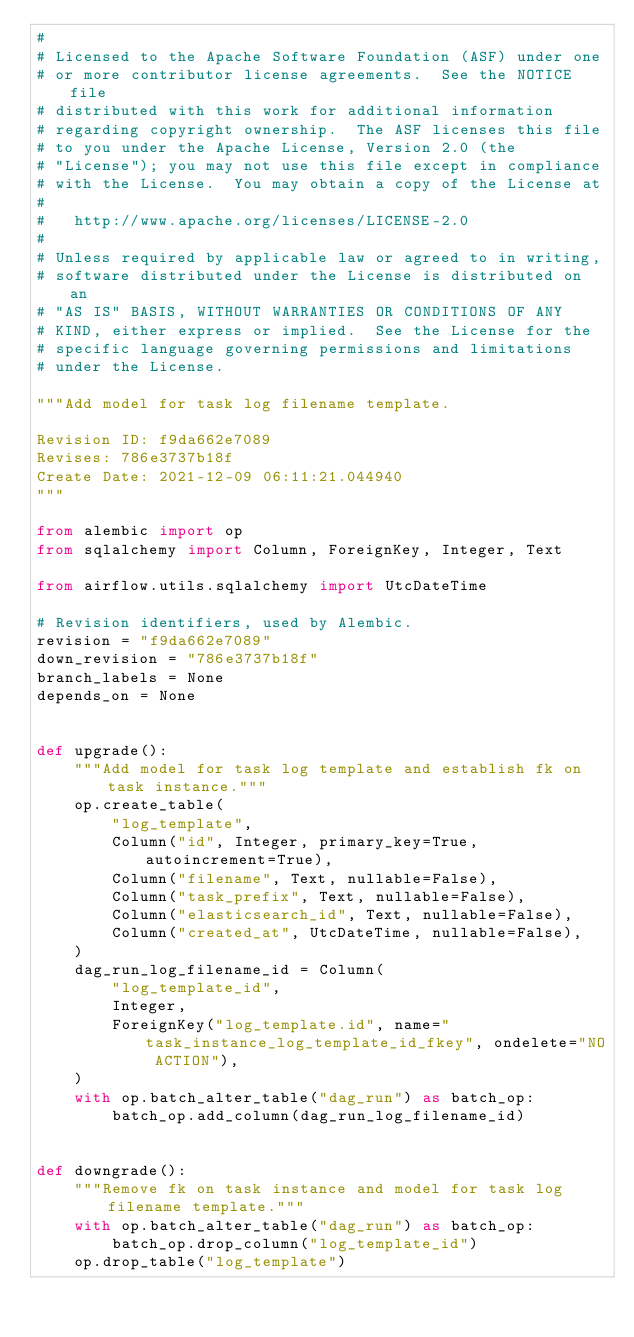<code> <loc_0><loc_0><loc_500><loc_500><_Python_>#
# Licensed to the Apache Software Foundation (ASF) under one
# or more contributor license agreements.  See the NOTICE file
# distributed with this work for additional information
# regarding copyright ownership.  The ASF licenses this file
# to you under the Apache License, Version 2.0 (the
# "License"); you may not use this file except in compliance
# with the License.  You may obtain a copy of the License at
#
#   http://www.apache.org/licenses/LICENSE-2.0
#
# Unless required by applicable law or agreed to in writing,
# software distributed under the License is distributed on an
# "AS IS" BASIS, WITHOUT WARRANTIES OR CONDITIONS OF ANY
# KIND, either express or implied.  See the License for the
# specific language governing permissions and limitations
# under the License.

"""Add model for task log filename template.

Revision ID: f9da662e7089
Revises: 786e3737b18f
Create Date: 2021-12-09 06:11:21.044940
"""

from alembic import op
from sqlalchemy import Column, ForeignKey, Integer, Text

from airflow.utils.sqlalchemy import UtcDateTime

# Revision identifiers, used by Alembic.
revision = "f9da662e7089"
down_revision = "786e3737b18f"
branch_labels = None
depends_on = None


def upgrade():
    """Add model for task log template and establish fk on task instance."""
    op.create_table(
        "log_template",
        Column("id", Integer, primary_key=True, autoincrement=True),
        Column("filename", Text, nullable=False),
        Column("task_prefix", Text, nullable=False),
        Column("elasticsearch_id", Text, nullable=False),
        Column("created_at", UtcDateTime, nullable=False),
    )
    dag_run_log_filename_id = Column(
        "log_template_id",
        Integer,
        ForeignKey("log_template.id", name="task_instance_log_template_id_fkey", ondelete="NO ACTION"),
    )
    with op.batch_alter_table("dag_run") as batch_op:
        batch_op.add_column(dag_run_log_filename_id)


def downgrade():
    """Remove fk on task instance and model for task log filename template."""
    with op.batch_alter_table("dag_run") as batch_op:
        batch_op.drop_column("log_template_id")
    op.drop_table("log_template")
</code> 